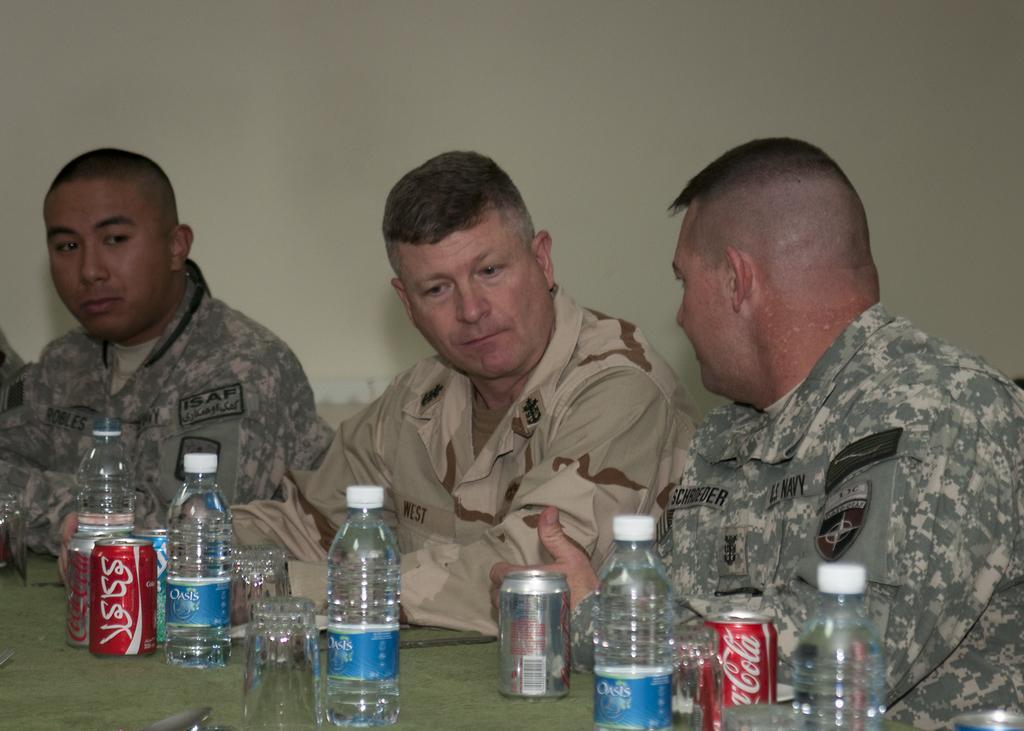How would you summarize this image in a sentence or two? In this image I see 3 men who are sitting and there are lot of bottles, glasses and cans in front of them. 